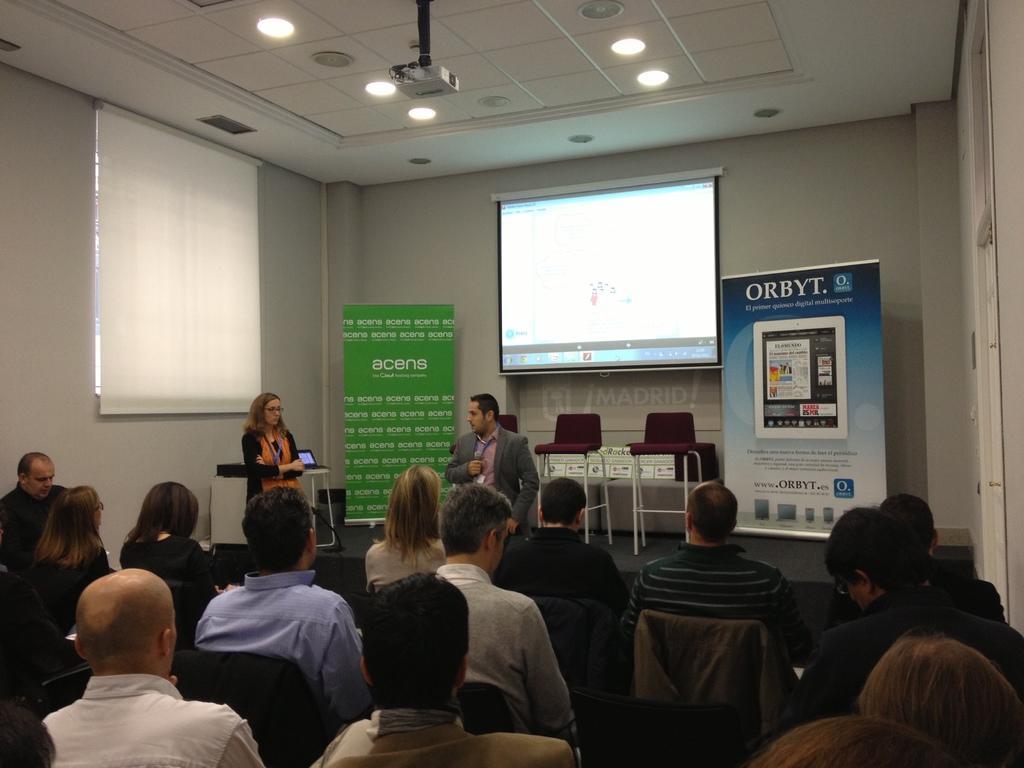Can you describe this image briefly? There is a group of persons sitting on the chairs at the bottom of this image, and there are two persons standing in the middle of this image, and there are some tables on the right side to this person. There are two posters and a screen at the top side to this person. There is a white color board on the left side of this image, and there is a wall in the background, There is a projector and some lights at the top of this image. 